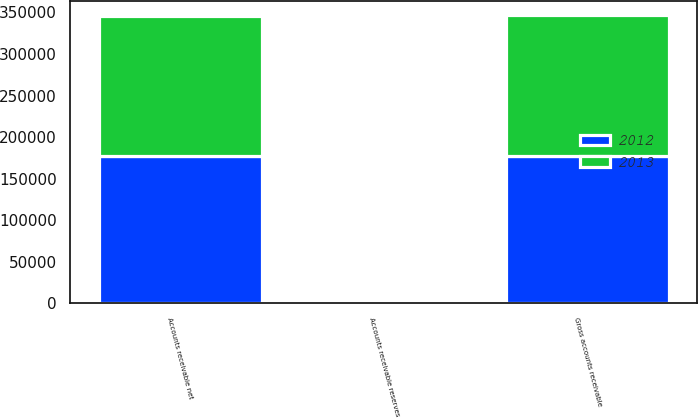<chart> <loc_0><loc_0><loc_500><loc_500><stacked_bar_chart><ecel><fcel>Gross accounts receivable<fcel>Accounts receivable reserves<fcel>Accounts receivable net<nl><fcel>2012<fcel>177370<fcel>453<fcel>176917<nl><fcel>2013<fcel>169401<fcel>669<fcel>168732<nl></chart> 